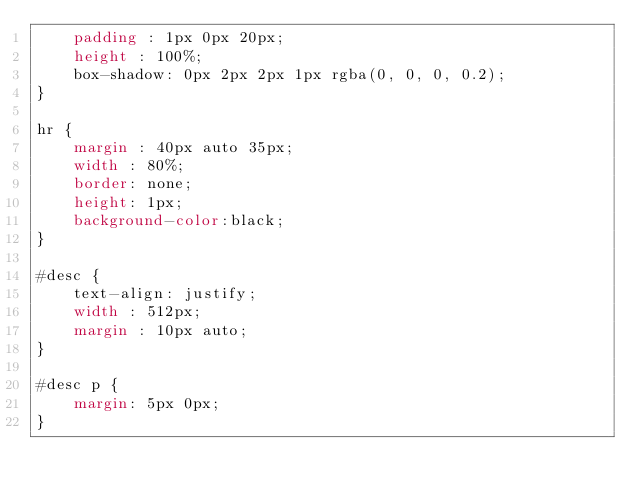<code> <loc_0><loc_0><loc_500><loc_500><_CSS_>    padding : 1px 0px 20px;
    height : 100%;
    box-shadow: 0px 2px 2px 1px rgba(0, 0, 0, 0.2);
}

hr {
    margin : 40px auto 35px;
    width : 80%;
    border: none;
    height: 1px;
    background-color:black;
}

#desc {
    text-align: justify;
    width : 512px;
    margin : 10px auto;
} 

#desc p {
    margin: 5px 0px;
}
</code> 